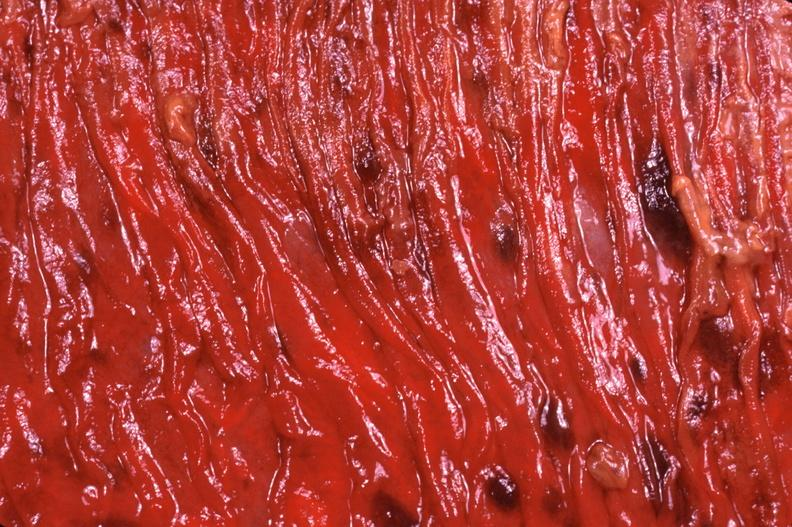what does this image show?
Answer the question using a single word or phrase. Duodenum 